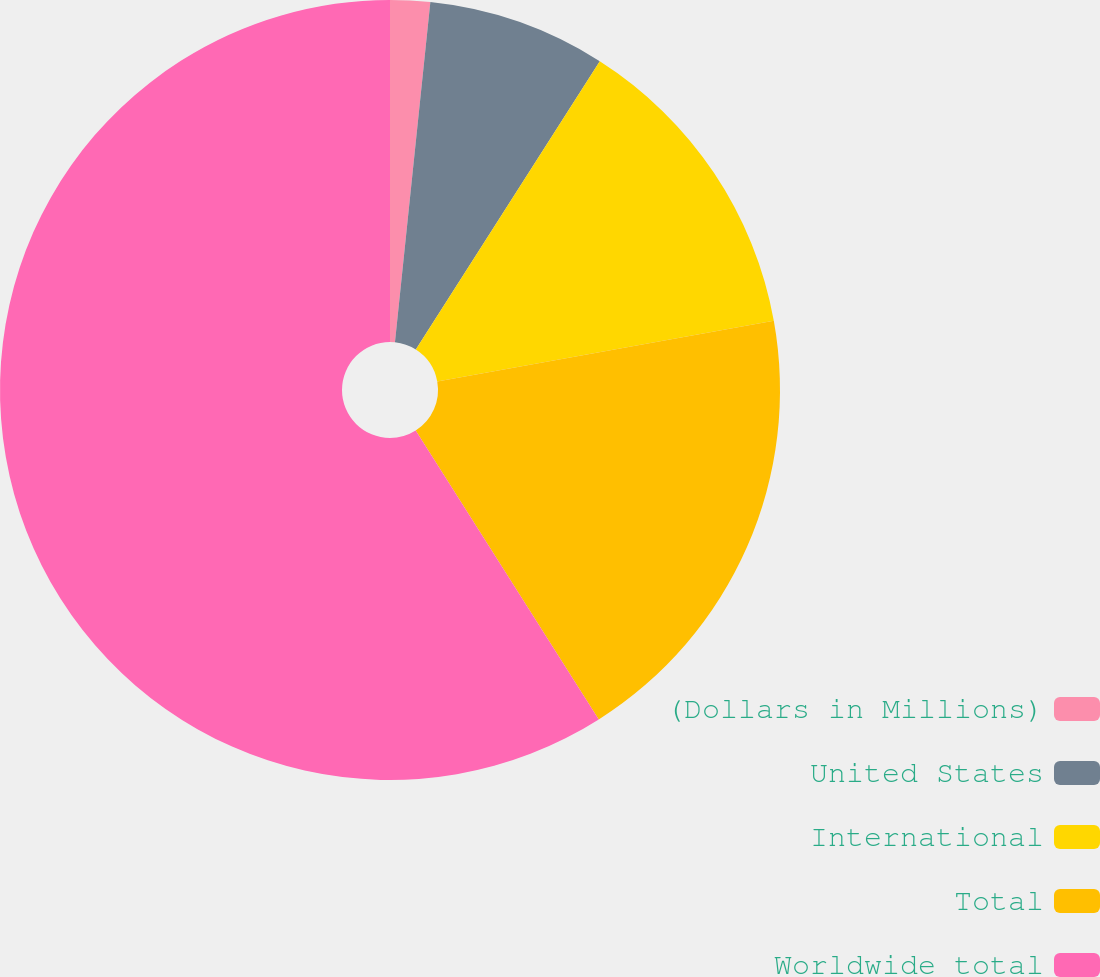Convert chart. <chart><loc_0><loc_0><loc_500><loc_500><pie_chart><fcel>(Dollars in Millions)<fcel>United States<fcel>International<fcel>Total<fcel>Worldwide total<nl><fcel>1.65%<fcel>7.39%<fcel>13.12%<fcel>18.85%<fcel>58.99%<nl></chart> 